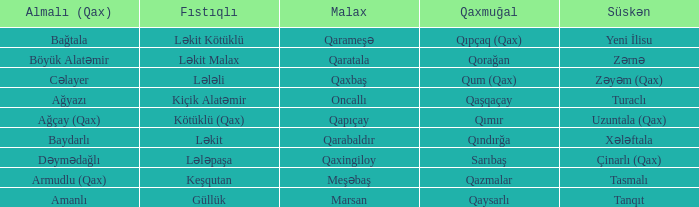What is the Süskən village with a Malax village meşəbaş? Tasmalı. 